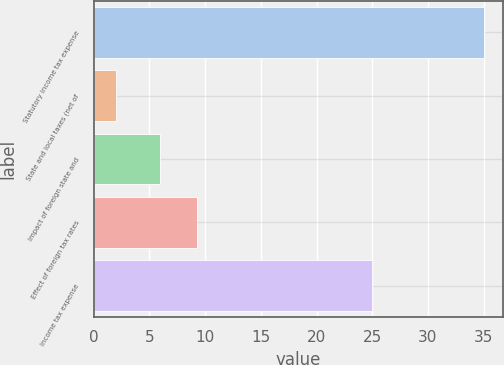Convert chart. <chart><loc_0><loc_0><loc_500><loc_500><bar_chart><fcel>Statutory income tax expense<fcel>State and local taxes (net of<fcel>Impact of foreign state and<fcel>Effect of foreign tax rates<fcel>Income tax expense<nl><fcel>35<fcel>2<fcel>6<fcel>9.3<fcel>25<nl></chart> 